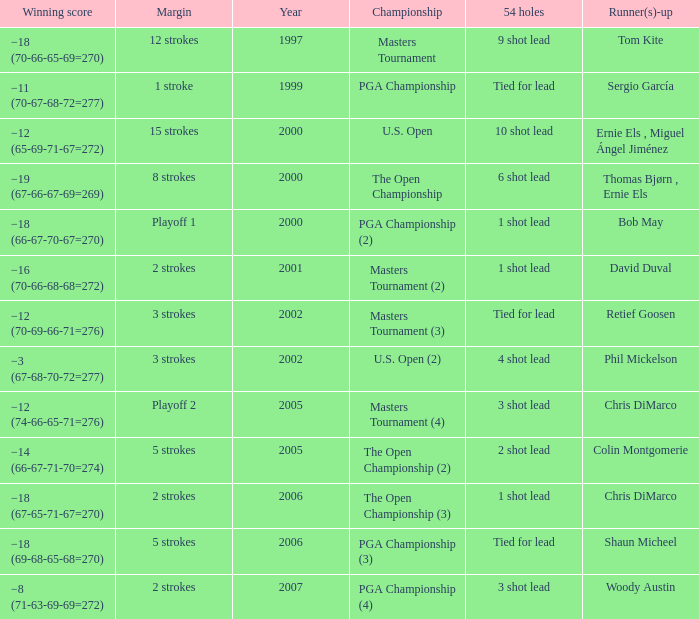 who is the runner(s)-up where 54 holes is tied for lead and margin is 5 strokes Shaun Micheel. 